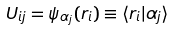<formula> <loc_0><loc_0><loc_500><loc_500>U _ { i j } = \psi _ { \alpha _ { j } } ( r _ { i } ) \equiv \langle r _ { i } | \alpha _ { j } \rangle</formula> 